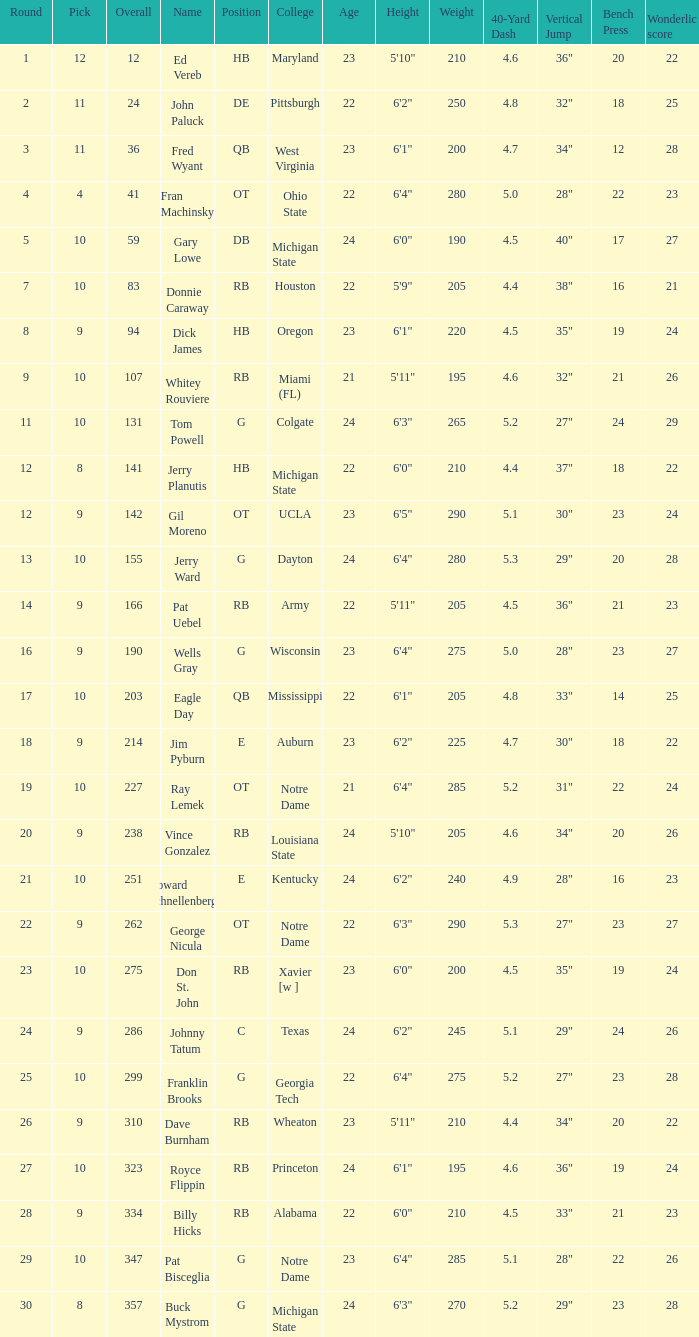What is the highest overall pick number for george nicula who had a pick smaller than 9? None. 